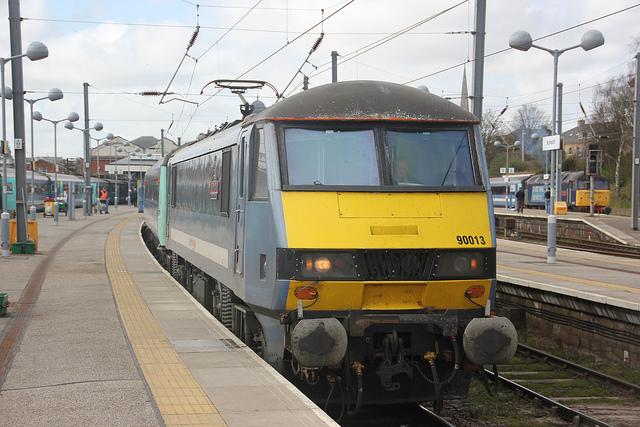How many points of contact between the train and the cables?
Give a very brief answer. 2. Are the lights on the train on?
Keep it brief. Yes. Is the train being boarded?
Be succinct. No. Are there people on the platform?
Short answer required. Yes. What number is on the train?
Be succinct. 90013. 